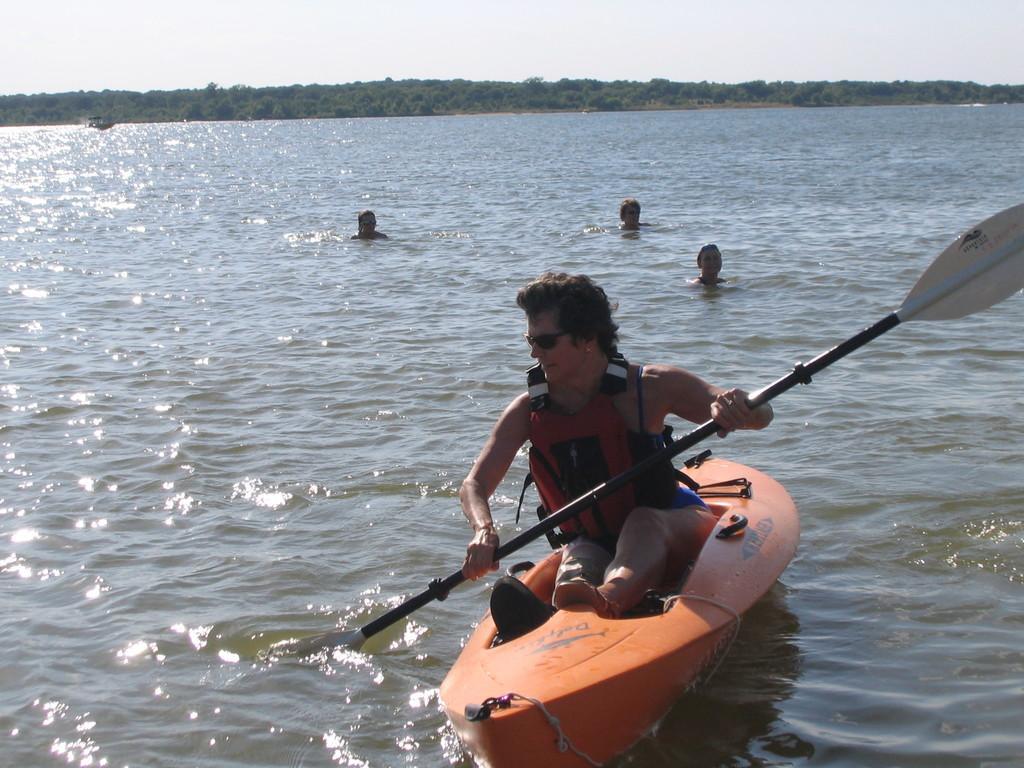Please provide a concise description of this image. In this picture we can see a boat and group of people, we can see a man, he is seated in the boat, and we can find few people in the water, in the background we can see few trees. 